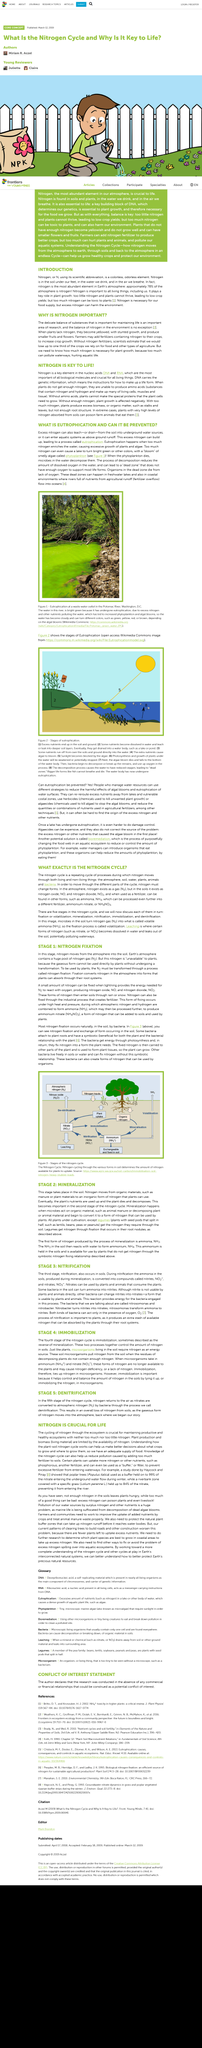Indicate a few pertinent items in this graphic. Figure 2 illustrates the progression of eutrophication, which is the process by which a body of water becomes enriched with nutrients and experiences an increase in the growth of aquatic plants and algae. Most nitrogen fixation occurs in the soil. Eutrophication is the buildup of excess nitrogen in water, leading to an overabundance of aquatic plant and animal life. Eutrophication can be prevented through the implementation of effective management strategies that reduce the harmful effects of algal blooms and the eutrophication of water surfaces. People have the ability to take action and prevent this environmental issue from worsening. The water in the image of the river is bright green due to eutrophication, which has resulted in an excess of phytoplankton and algal blooms. 